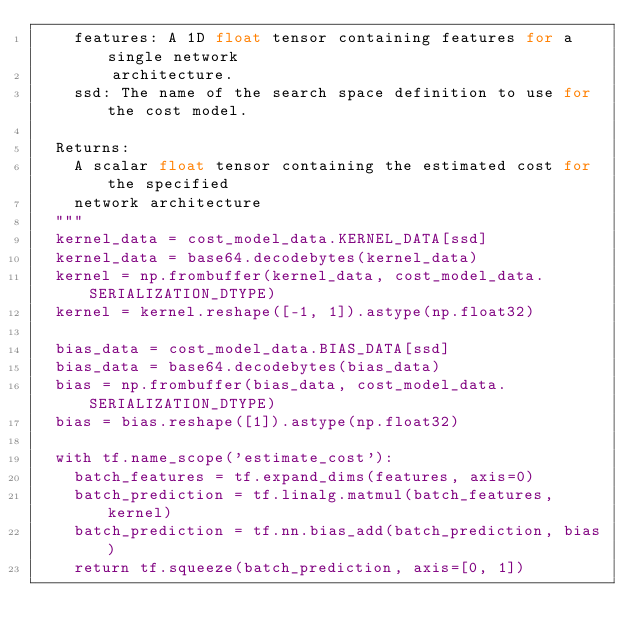<code> <loc_0><loc_0><loc_500><loc_500><_Python_>    features: A 1D float tensor containing features for a single network
        architecture.
    ssd: The name of the search space definition to use for the cost model.

  Returns:
    A scalar float tensor containing the estimated cost for the specified
    network architecture
  """
  kernel_data = cost_model_data.KERNEL_DATA[ssd]
  kernel_data = base64.decodebytes(kernel_data)
  kernel = np.frombuffer(kernel_data, cost_model_data.SERIALIZATION_DTYPE)
  kernel = kernel.reshape([-1, 1]).astype(np.float32)

  bias_data = cost_model_data.BIAS_DATA[ssd]
  bias_data = base64.decodebytes(bias_data)
  bias = np.frombuffer(bias_data, cost_model_data.SERIALIZATION_DTYPE)
  bias = bias.reshape([1]).astype(np.float32)

  with tf.name_scope('estimate_cost'):
    batch_features = tf.expand_dims(features, axis=0)
    batch_prediction = tf.linalg.matmul(batch_features, kernel)
    batch_prediction = tf.nn.bias_add(batch_prediction, bias)
    return tf.squeeze(batch_prediction, axis=[0, 1])
</code> 